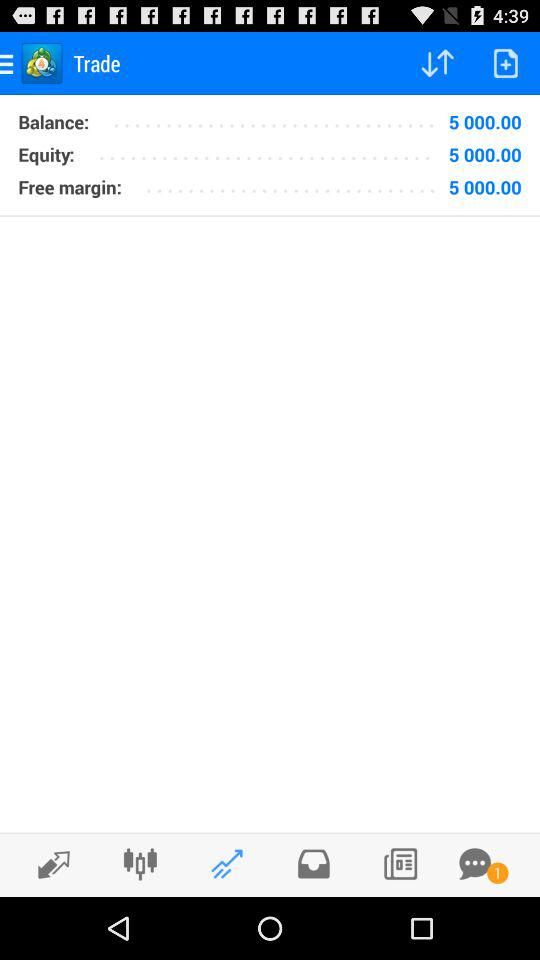What is the equity? The equity is 5000. 